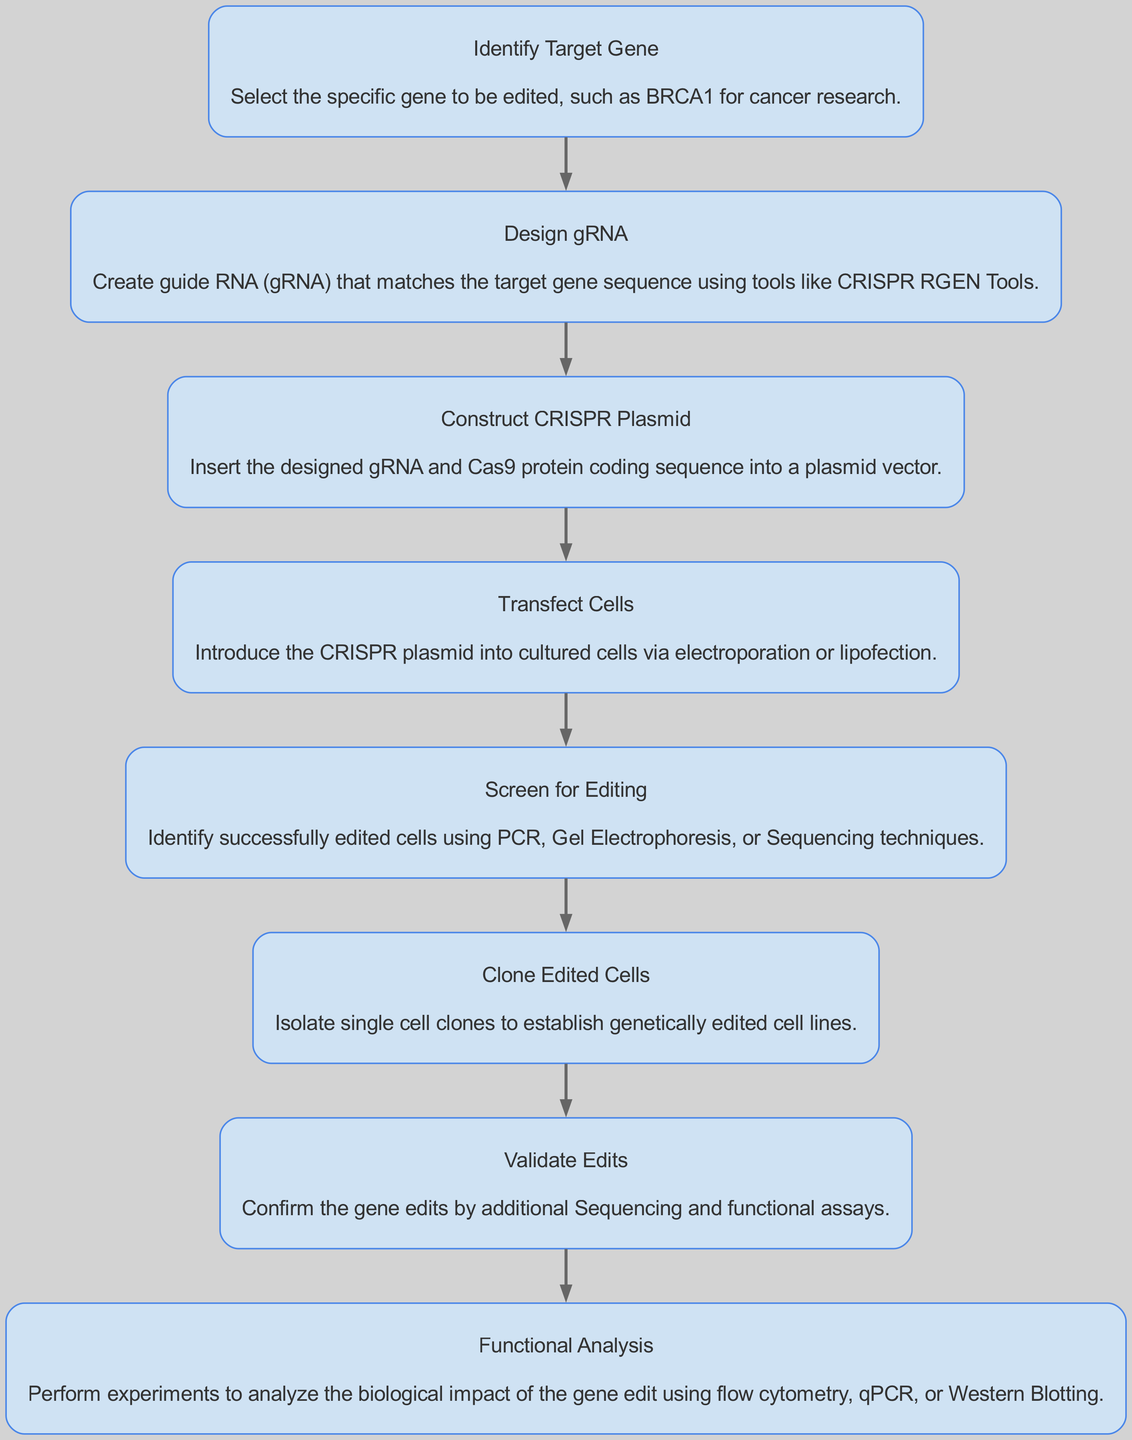What is the first step in the gene editing workflow? The first step is always to identify the target gene for the experiment. This is usually depicted as the top node in the diagram.
Answer: Identify Target Gene How many nodes are present in the diagram? By counting the distinct elements or steps shown in the diagram, we find a total of eight nodes. Each node represents a unique stage in the gene editing process.
Answer: Eight What stage comes after designing gRNA? The workflow indicates that constructing the CRISPR plasmid follows the design of gRNA, highlighting the sequence of actions taken in the process.
Answer: Construct CRISPR Plasmid Which step involves confirming the gene edits? The step dedicated to validating edits in the diagram specifically mentions confirming the gene modifications made during the experiment.
Answer: Validate Edits What techniques are suggested for screening edited cells? In the diagram, several methods such as PCR, Gel Electrophoresis, and Sequencing are mentioned for screening edited cells, showing the diverse approaches to confirming edits.
Answer: PCR, Gel Electrophoresis, Sequencing How is the CRISPR plasmid introduced into cells? The diagram states that transfection is the method used to introduce the CRISPR plasmid into cultured cells, which is a critical step in the workflow.
Answer: Transfect Cells What is the final step in the gene editing workflow? The final step shown in the diagram is the functional analysis, which focuses on evaluating the biological impact of the gene edits performed earlier in the workflow.
Answer: Functional Analysis In what order do the steps in the workflow appear? By following the directional flow of the diagram from top to bottom, the order is: Identify Target Gene, Design gRNA, Construct CRISPR Plasmid, Transfect Cells, Screen for Editing, Clone Edited Cells, Validate Edits, Functional Analysis.
Answer: Sequential order from top to bottom 